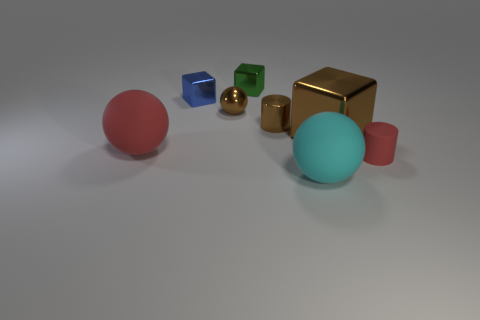Add 1 green objects. How many objects exist? 9 Subtract all big metallic blocks. How many blocks are left? 2 Subtract 3 balls. How many balls are left? 0 Subtract all brown cylinders. How many cylinders are left? 1 Subtract all cubes. How many objects are left? 5 Add 3 brown metallic blocks. How many brown metallic blocks are left? 4 Add 3 small brown balls. How many small brown balls exist? 4 Subtract 0 blue balls. How many objects are left? 8 Subtract all yellow blocks. Subtract all red cylinders. How many blocks are left? 3 Subtract all purple spheres. How many red blocks are left? 0 